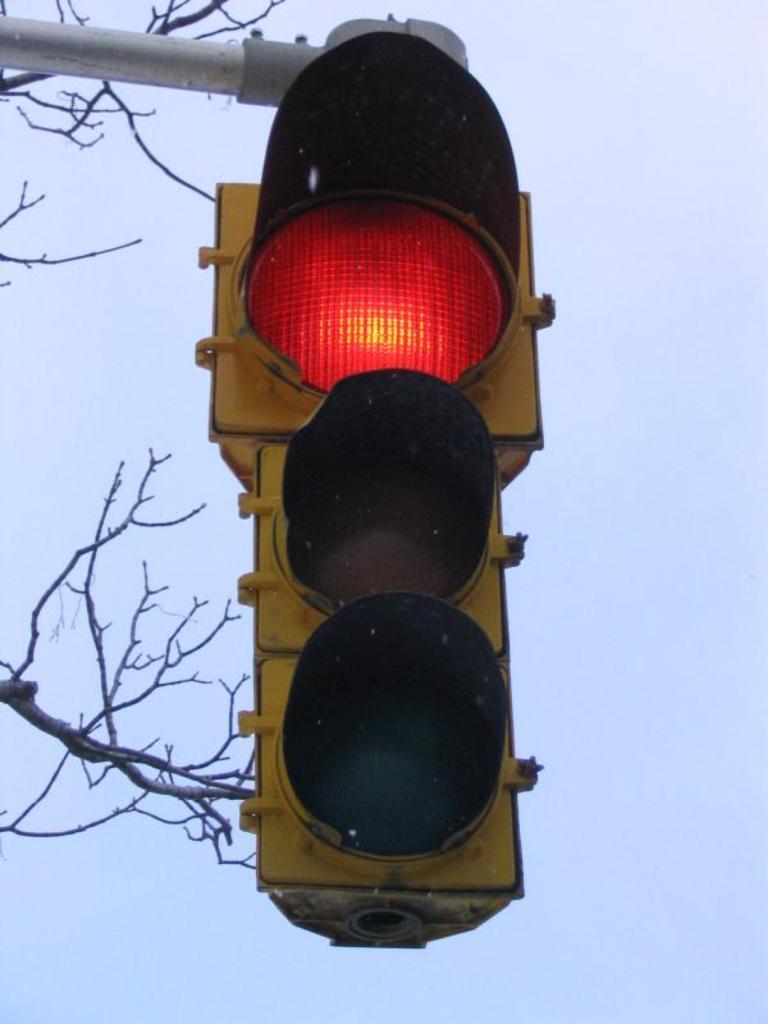Could you give a brief overview of what you see in this image? In this picture we can see a traffic signal attached to a pole, branches and stems. In the background of the image we can see the sky. 